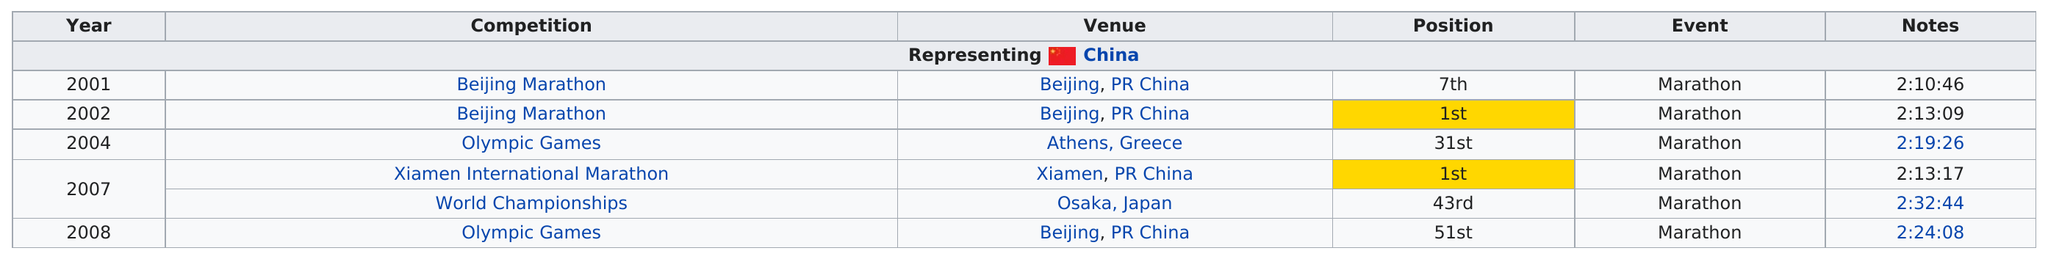List a handful of essential elements in this visual. In Beijing, 3 marathons were held. The venue in Athens, Greece, was associated with 31st place. The number of marathons that have been part of the Olympic Games is two. The runner obtained the 51st and 31st positions at the Olympic Games competition. The Beijing Marathon was the first competition of its kind. 